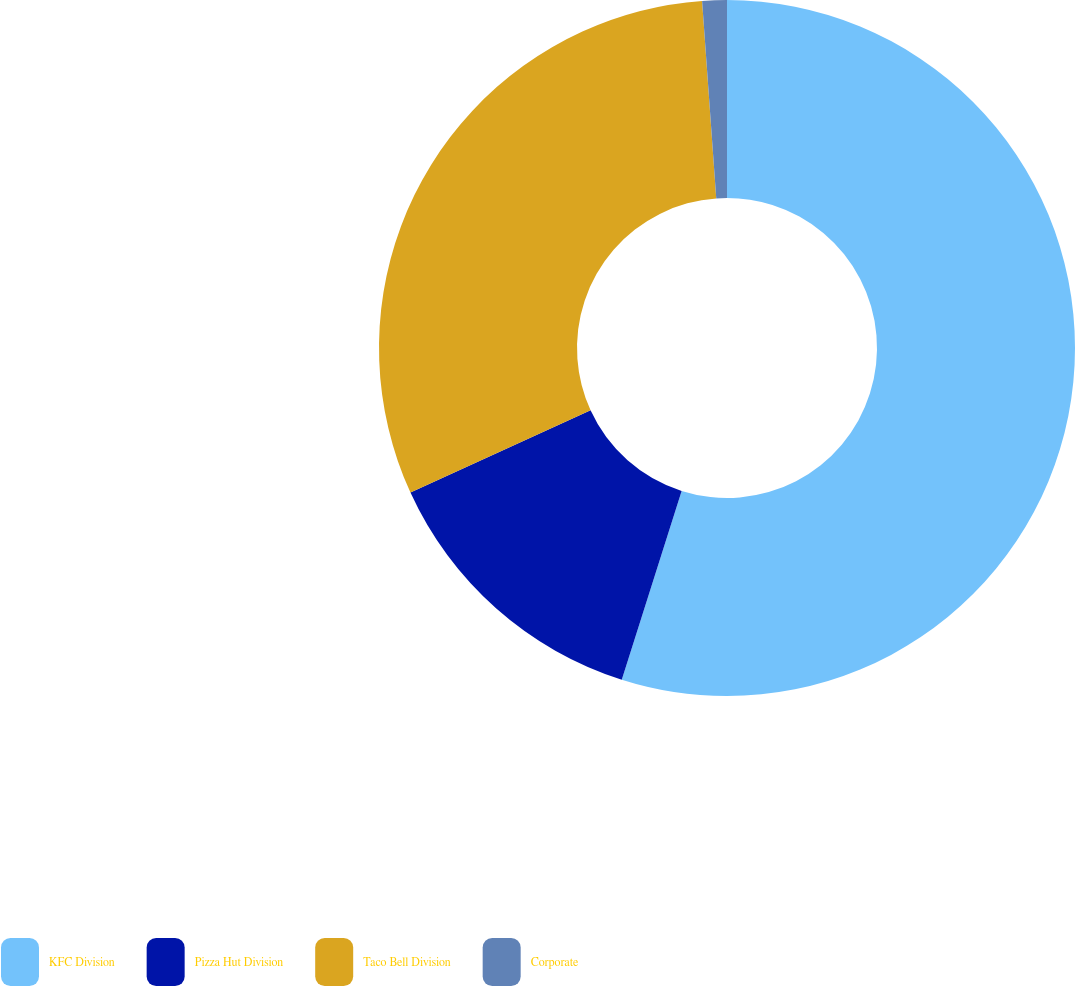<chart> <loc_0><loc_0><loc_500><loc_500><pie_chart><fcel>KFC Division<fcel>Pizza Hut Division<fcel>Taco Bell Division<fcel>Corporate<nl><fcel>54.89%<fcel>13.29%<fcel>30.68%<fcel>1.14%<nl></chart> 